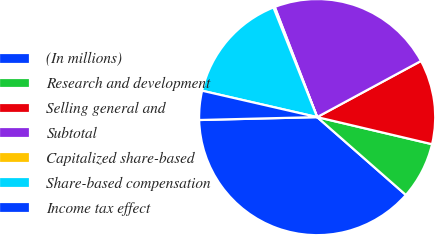<chart> <loc_0><loc_0><loc_500><loc_500><pie_chart><fcel>(In millions)<fcel>Research and development<fcel>Selling general and<fcel>Subtotal<fcel>Capitalized share-based<fcel>Share-based compensation<fcel>Income tax effect<nl><fcel>38.14%<fcel>7.78%<fcel>11.57%<fcel>22.96%<fcel>0.19%<fcel>15.37%<fcel>3.98%<nl></chart> 